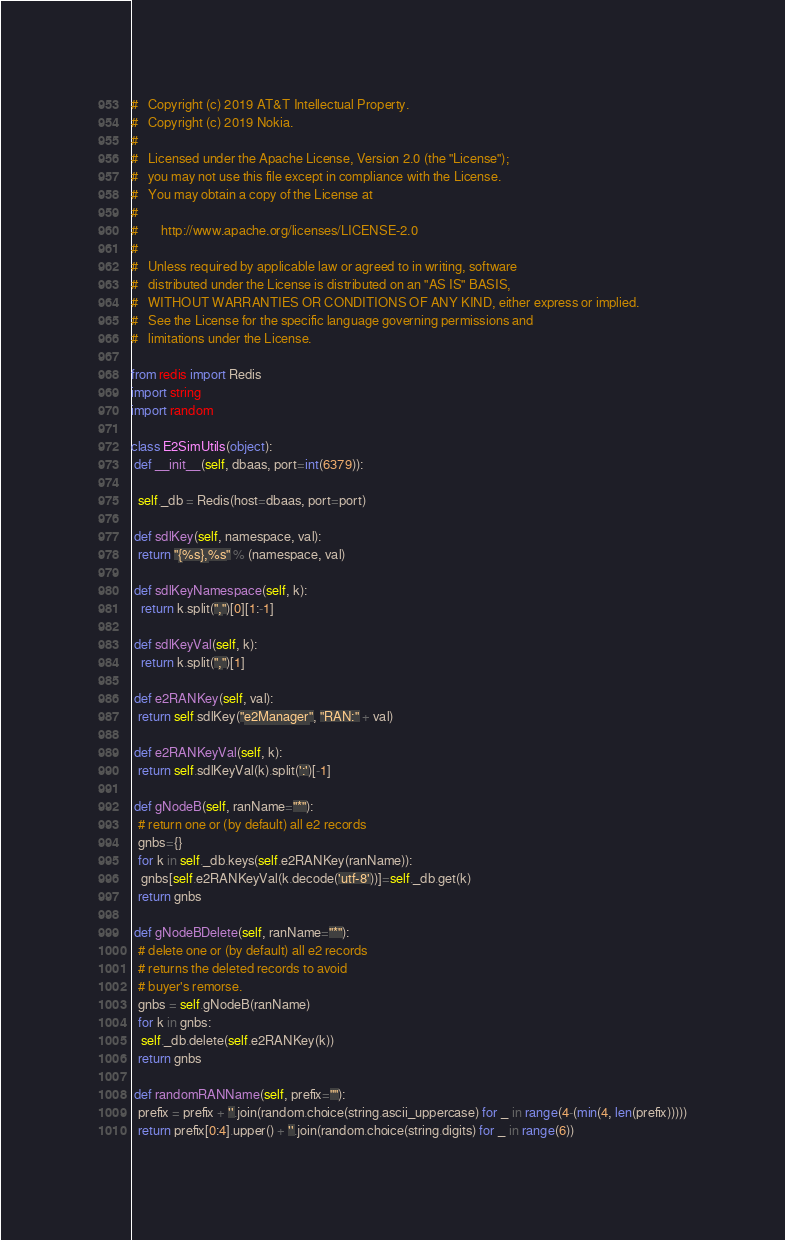Convert code to text. <code><loc_0><loc_0><loc_500><loc_500><_Python_>#   Copyright (c) 2019 AT&T Intellectual Property.
#   Copyright (c) 2019 Nokia.
#
#   Licensed under the Apache License, Version 2.0 (the "License");
#   you may not use this file except in compliance with the License.
#   You may obtain a copy of the License at
#
#       http://www.apache.org/licenses/LICENSE-2.0
#
#   Unless required by applicable law or agreed to in writing, software
#   distributed under the License is distributed on an "AS IS" BASIS,
#   WITHOUT WARRANTIES OR CONDITIONS OF ANY KIND, either express or implied.
#   See the License for the specific language governing permissions and
#   limitations under the License.

from redis import Redis
import string
import random

class E2SimUtils(object):
 def __init__(self, dbaas, port=int(6379)):

  self._db = Redis(host=dbaas, port=port)

 def sdlKey(self, namespace, val):
  return "{%s},%s" % (namespace, val)

 def sdlKeyNamespace(self, k):
   return k.split(",")[0][1:-1]

 def sdlKeyVal(self, k):
   return k.split(",")[1]

 def e2RANKey(self, val):
  return self.sdlKey("e2Manager", "RAN:" + val)

 def e2RANKeyVal(self, k):
  return self.sdlKeyVal(k).split(':')[-1]

 def gNodeB(self, ranName="*"):
  # return one or (by default) all e2 records
  gnbs={}
  for k in self._db.keys(self.e2RANKey(ranName)):
   gnbs[self.e2RANKeyVal(k.decode('utf-8'))]=self._db.get(k)
  return gnbs

 def gNodeBDelete(self, ranName="*"):
  # delete one or (by default) all e2 records
  # returns the deleted records to avoid
  # buyer's remorse.
  gnbs = self.gNodeB(ranName)
  for k in gnbs:
   self._db.delete(self.e2RANKey(k))
  return gnbs

 def randomRANName(self, prefix=""):
  prefix = prefix + ''.join(random.choice(string.ascii_uppercase) for _ in range(4-(min(4, len(prefix)))))
  return prefix[0:4].upper() + ''.join(random.choice(string.digits) for _ in range(6))
</code> 